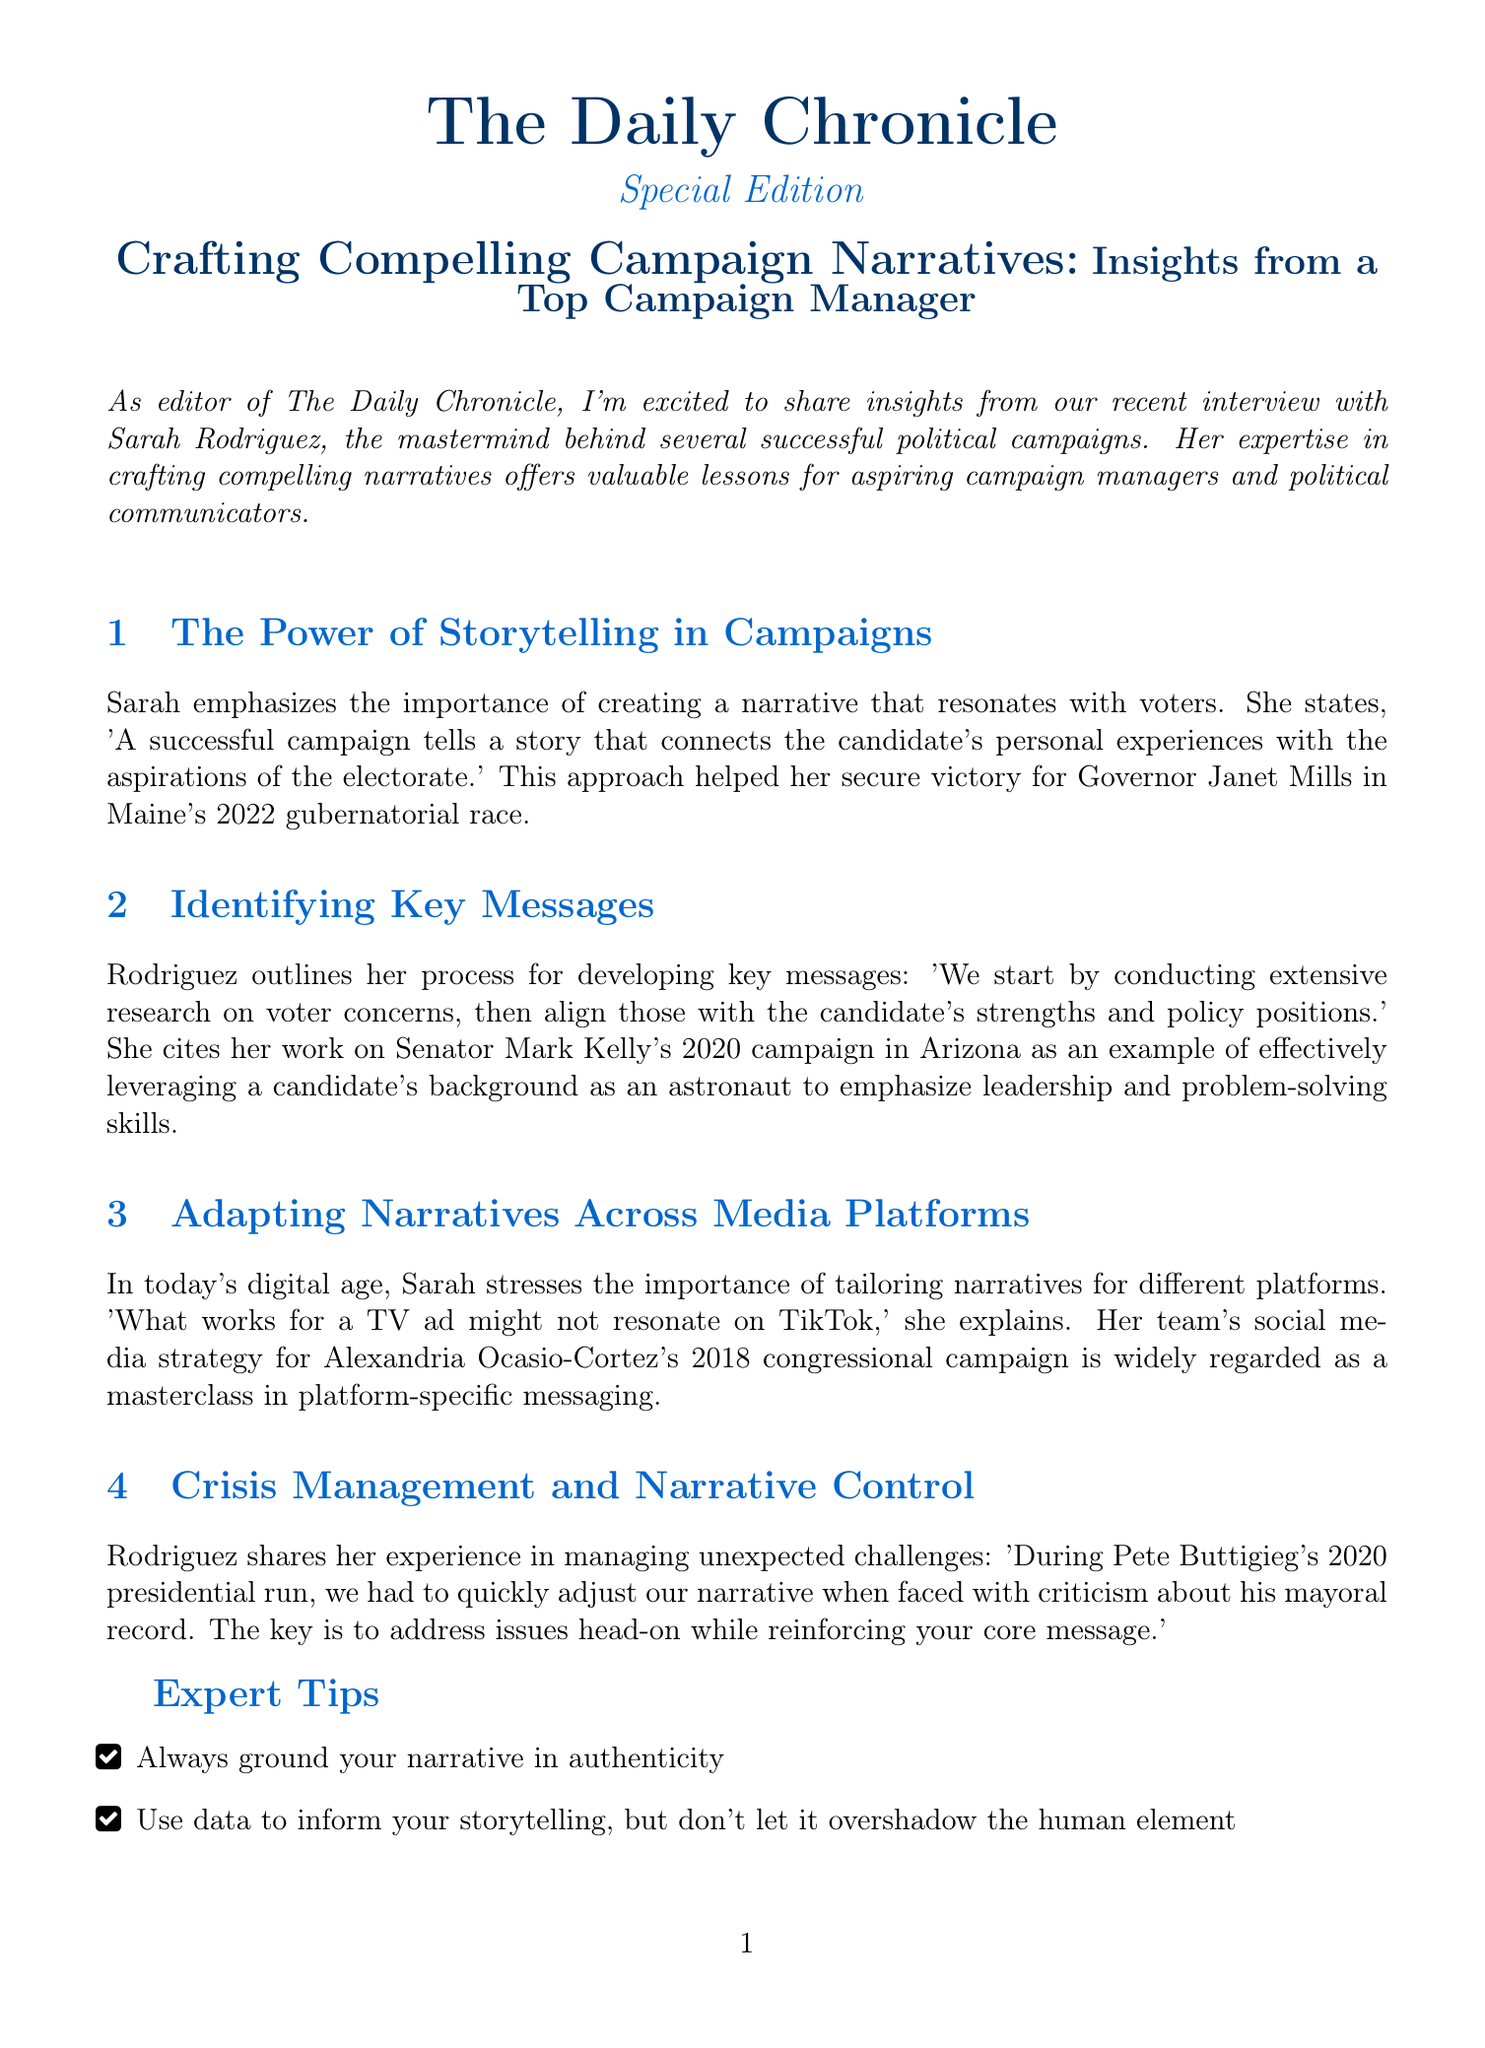What is the title of the newsletter? The title of the newsletter is provided at the beginning and indicates the main focus of the content.
Answer: Crafting Compelling Campaign Narratives: Insights from a Top Campaign Manager Who is interviewed in the newsletter? The newsletter explicitly states the name of the expert being interviewed, whose insights are shared in the document.
Answer: Sarah Rodriguez What is one key aspect of storytelling emphasized by Sarah? Sarah highlights a specific element important in creating narratives for campaigns, which reflects her strategic approach.
Answer: Connecting personal experiences with voter aspirations What campaign did Sarah manage for Governor Mills? The document mentions a specific race where Sarah was successful, indicating her significant role in that campaign.
Answer: 2022 gubernatorial race Which medium does Sarah suggest tailoring narratives for? The document includes statements from Sarah that target specific communication mediums used in campaigns.
Answer: Different platforms What is one of Sarah's expert tips? The newsletter lists specific strategies shared by Sarah that can enhance campaign narratives.
Answer: Always ground your narrative in authenticity During which campaign did Sarah manage crisis challenges? The document refers to a particular campaign context where Sarah faced unexpected challenges and adjusted narratives.
Answer: Pete Buttigieg's 2020 presidential run What year was Mark Kelly's campaign? The document provides a timeline related to past campaigns Sarah has worked on, pointing to a specific campaign year for clarity.
Answer: 2020 